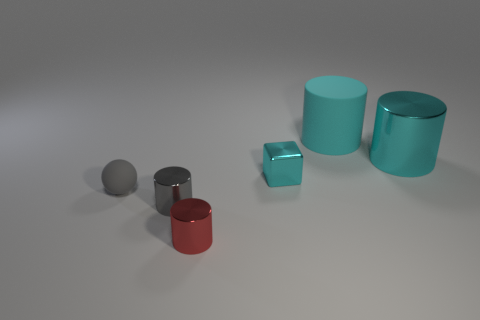From a design perspective, what does this image tell us about the use of color and form? The image presents a minimalistic and modern aesthetic. The use of primary colors with a single, less saturated tint creates a harmonious yet bold contrast. Form-wise, the simplicity of geometric shapes like cubes and cylinders speaks to foundational design principles, emphasizing how basic forms can create a visually compelling scene. How might the principles demonstrated here be applied to real-world design? These principles are central to product and interior design, where form and color are used to evoke emotion, ensure user friendliness, or complement environmental context. The balance and contrast shown here can be applied to create visually pleasing and functional spaces or objects. 